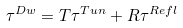Convert formula to latex. <formula><loc_0><loc_0><loc_500><loc_500>\tau ^ { D w } = T \tau ^ { T u n } + R \tau ^ { R e f l }</formula> 